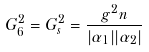<formula> <loc_0><loc_0><loc_500><loc_500>G ^ { 2 } _ { 6 } = G _ { s } ^ { 2 } = \frac { g ^ { 2 } n } { | \alpha _ { 1 } | | \alpha _ { 2 } | }</formula> 